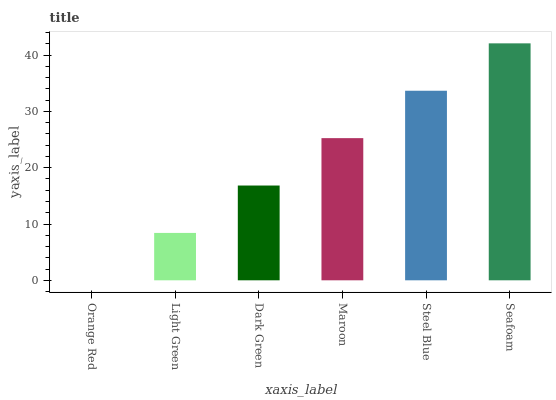Is Light Green the minimum?
Answer yes or no. No. Is Light Green the maximum?
Answer yes or no. No. Is Light Green greater than Orange Red?
Answer yes or no. Yes. Is Orange Red less than Light Green?
Answer yes or no. Yes. Is Orange Red greater than Light Green?
Answer yes or no. No. Is Light Green less than Orange Red?
Answer yes or no. No. Is Maroon the high median?
Answer yes or no. Yes. Is Dark Green the low median?
Answer yes or no. Yes. Is Dark Green the high median?
Answer yes or no. No. Is Steel Blue the low median?
Answer yes or no. No. 